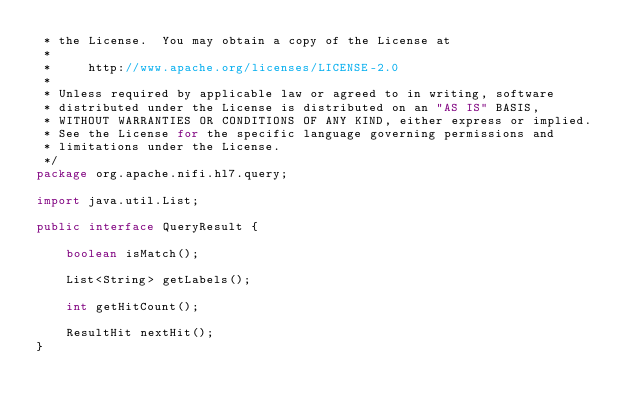<code> <loc_0><loc_0><loc_500><loc_500><_Java_> * the License.  You may obtain a copy of the License at
 *
 *     http://www.apache.org/licenses/LICENSE-2.0
 *
 * Unless required by applicable law or agreed to in writing, software
 * distributed under the License is distributed on an "AS IS" BASIS,
 * WITHOUT WARRANTIES OR CONDITIONS OF ANY KIND, either express or implied.
 * See the License for the specific language governing permissions and
 * limitations under the License.
 */
package org.apache.nifi.hl7.query;

import java.util.List;

public interface QueryResult {

    boolean isMatch();

    List<String> getLabels();

    int getHitCount();

    ResultHit nextHit();
}
</code> 